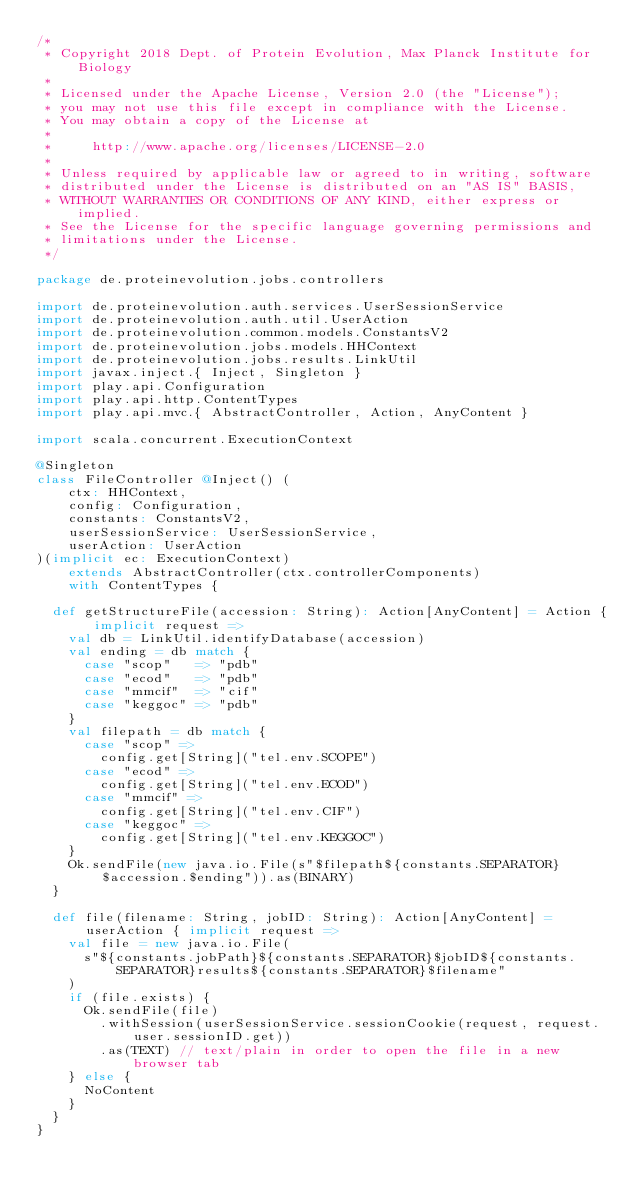Convert code to text. <code><loc_0><loc_0><loc_500><loc_500><_Scala_>/*
 * Copyright 2018 Dept. of Protein Evolution, Max Planck Institute for Biology
 *
 * Licensed under the Apache License, Version 2.0 (the "License");
 * you may not use this file except in compliance with the License.
 * You may obtain a copy of the License at
 *
 *     http://www.apache.org/licenses/LICENSE-2.0
 *
 * Unless required by applicable law or agreed to in writing, software
 * distributed under the License is distributed on an "AS IS" BASIS,
 * WITHOUT WARRANTIES OR CONDITIONS OF ANY KIND, either express or implied.
 * See the License for the specific language governing permissions and
 * limitations under the License.
 */

package de.proteinevolution.jobs.controllers

import de.proteinevolution.auth.services.UserSessionService
import de.proteinevolution.auth.util.UserAction
import de.proteinevolution.common.models.ConstantsV2
import de.proteinevolution.jobs.models.HHContext
import de.proteinevolution.jobs.results.LinkUtil
import javax.inject.{ Inject, Singleton }
import play.api.Configuration
import play.api.http.ContentTypes
import play.api.mvc.{ AbstractController, Action, AnyContent }

import scala.concurrent.ExecutionContext

@Singleton
class FileController @Inject() (
    ctx: HHContext,
    config: Configuration,
    constants: ConstantsV2,
    userSessionService: UserSessionService,
    userAction: UserAction
)(implicit ec: ExecutionContext)
    extends AbstractController(ctx.controllerComponents)
    with ContentTypes {

  def getStructureFile(accession: String): Action[AnyContent] = Action { implicit request =>
    val db = LinkUtil.identifyDatabase(accession)
    val ending = db match {
      case "scop"   => "pdb"
      case "ecod"   => "pdb"
      case "mmcif"  => "cif"
      case "keggoc" => "pdb"
    }
    val filepath = db match {
      case "scop" =>
        config.get[String]("tel.env.SCOPE")
      case "ecod" =>
        config.get[String]("tel.env.ECOD")
      case "mmcif" =>
        config.get[String]("tel.env.CIF")
      case "keggoc" =>
        config.get[String]("tel.env.KEGGOC")
    }
    Ok.sendFile(new java.io.File(s"$filepath${constants.SEPARATOR}$accession.$ending")).as(BINARY)
  }

  def file(filename: String, jobID: String): Action[AnyContent] = userAction { implicit request =>
    val file = new java.io.File(
      s"${constants.jobPath}${constants.SEPARATOR}$jobID${constants.SEPARATOR}results${constants.SEPARATOR}$filename"
    )
    if (file.exists) {
      Ok.sendFile(file)
        .withSession(userSessionService.sessionCookie(request, request.user.sessionID.get))
        .as(TEXT) // text/plain in order to open the file in a new browser tab
    } else {
      NoContent
    }
  }
}
</code> 